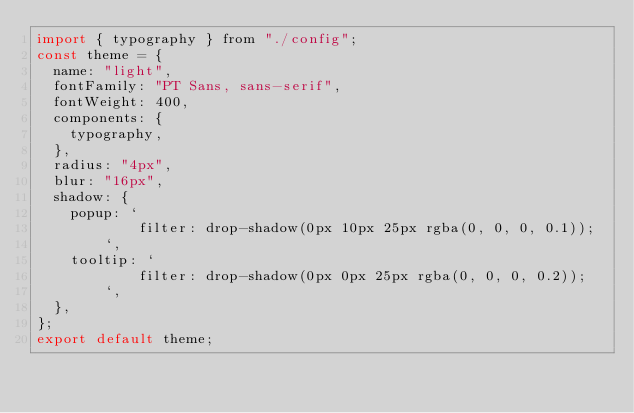Convert code to text. <code><loc_0><loc_0><loc_500><loc_500><_JavaScript_>import { typography } from "./config";
const theme = {
  name: "light",
  fontFamily: "PT Sans, sans-serif",
  fontWeight: 400,
  components: {
    typography,
  },
  radius: "4px",
  blur: "16px",
  shadow: {
    popup: `
            filter: drop-shadow(0px 10px 25px rgba(0, 0, 0, 0.1));
        `,
    tooltip: `
            filter: drop-shadow(0px 0px 25px rgba(0, 0, 0, 0.2));
        `,
  },
};
export default theme;
</code> 